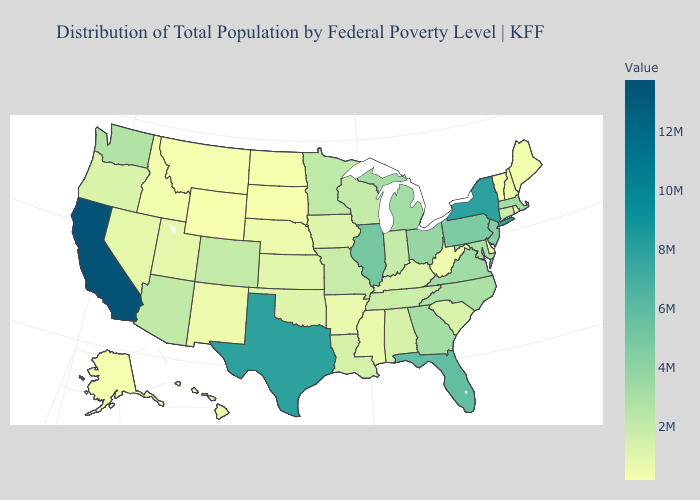Which states have the lowest value in the West?
Keep it brief. Wyoming. Among the states that border North Carolina , which have the lowest value?
Concise answer only. South Carolina. 